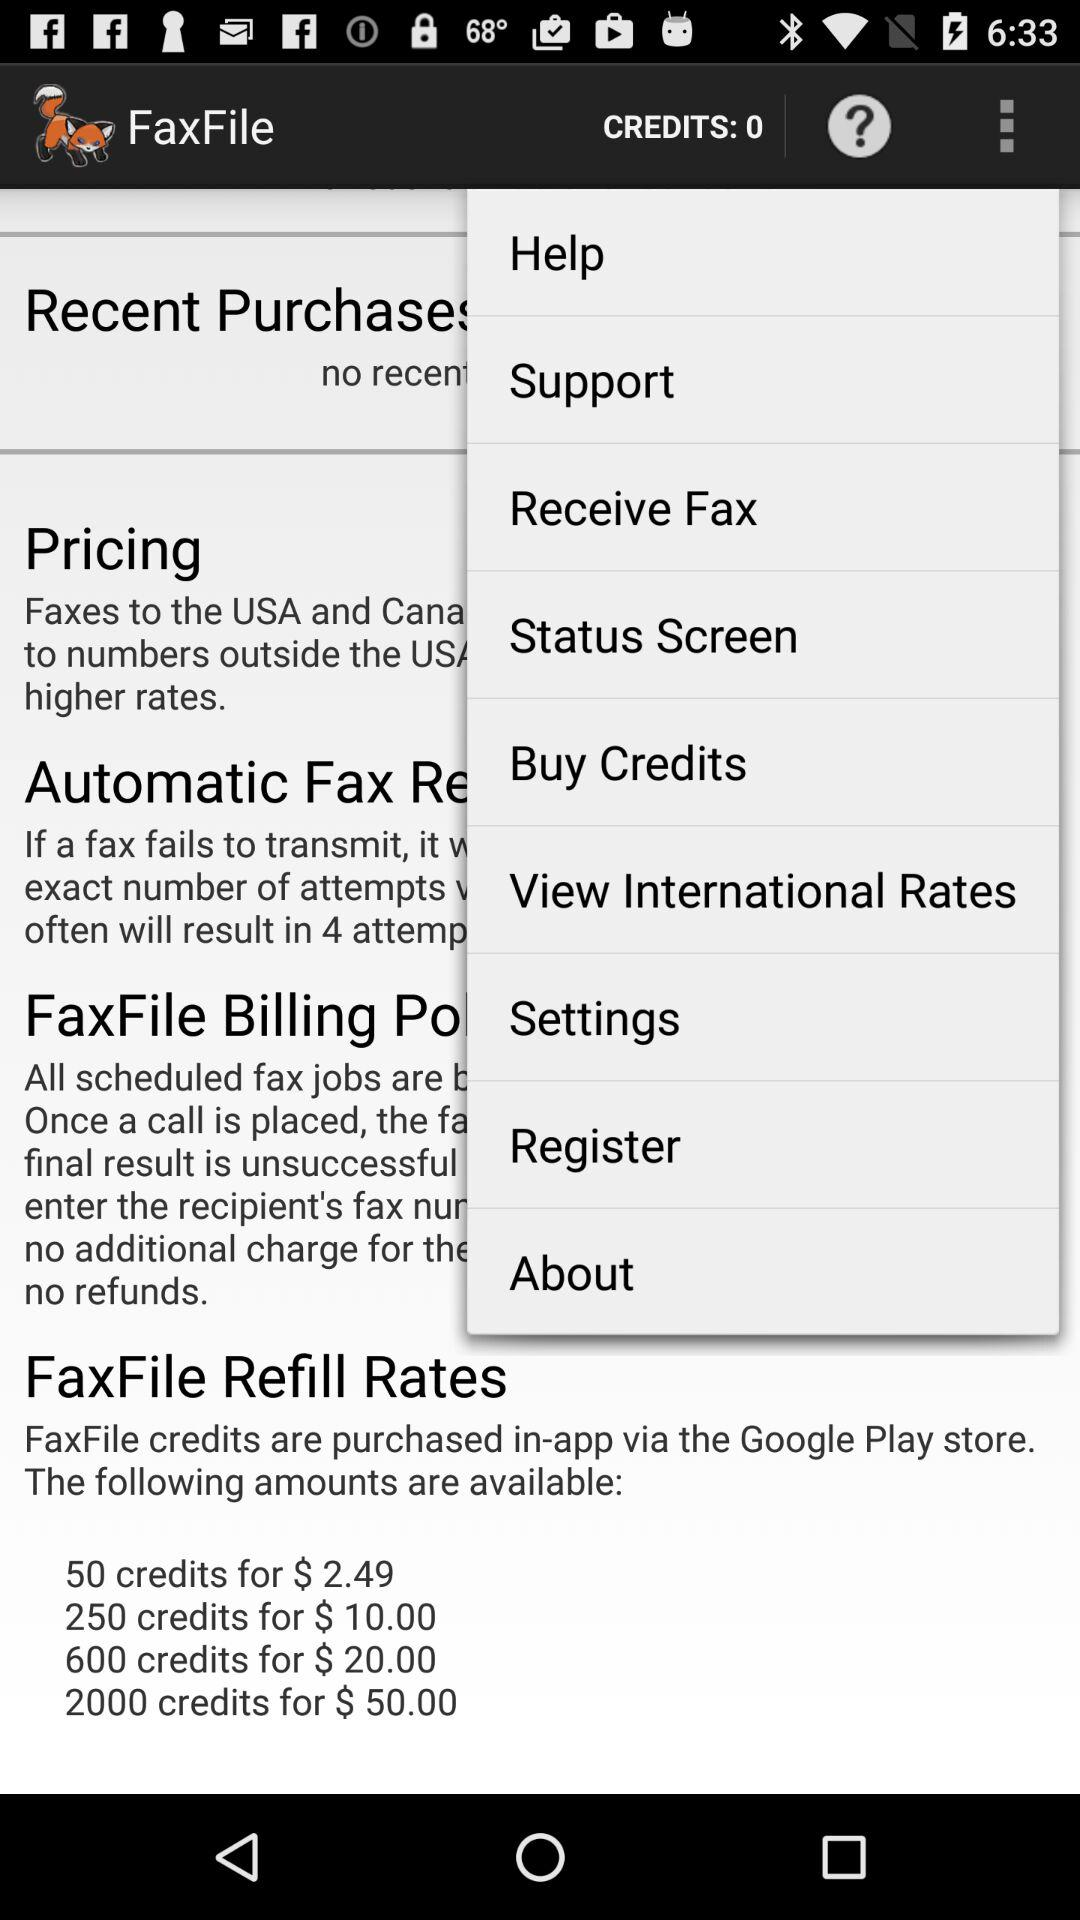How many credits are available in the largest package?
Answer the question using a single word or phrase. 2000 